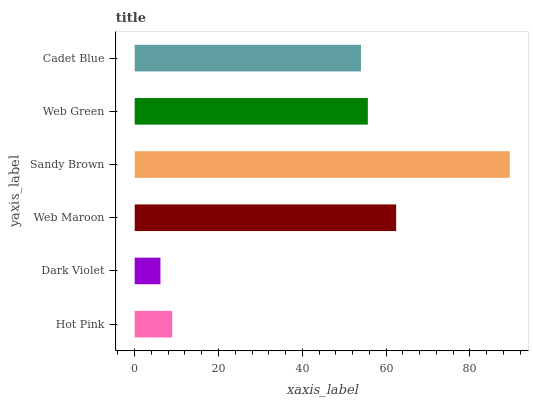Is Dark Violet the minimum?
Answer yes or no. Yes. Is Sandy Brown the maximum?
Answer yes or no. Yes. Is Web Maroon the minimum?
Answer yes or no. No. Is Web Maroon the maximum?
Answer yes or no. No. Is Web Maroon greater than Dark Violet?
Answer yes or no. Yes. Is Dark Violet less than Web Maroon?
Answer yes or no. Yes. Is Dark Violet greater than Web Maroon?
Answer yes or no. No. Is Web Maroon less than Dark Violet?
Answer yes or no. No. Is Web Green the high median?
Answer yes or no. Yes. Is Cadet Blue the low median?
Answer yes or no. Yes. Is Cadet Blue the high median?
Answer yes or no. No. Is Sandy Brown the low median?
Answer yes or no. No. 